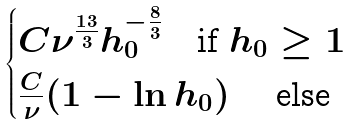<formula> <loc_0><loc_0><loc_500><loc_500>\begin{cases} C \nu ^ { \frac { 1 3 } 3 } h _ { 0 } ^ { - \frac { 8 } { 3 } } \quad \text {if } h _ { 0 } \geq 1 \\ \frac { C } { \nu } ( 1 - \ln h _ { 0 } ) \quad \text { else} \end{cases}</formula> 